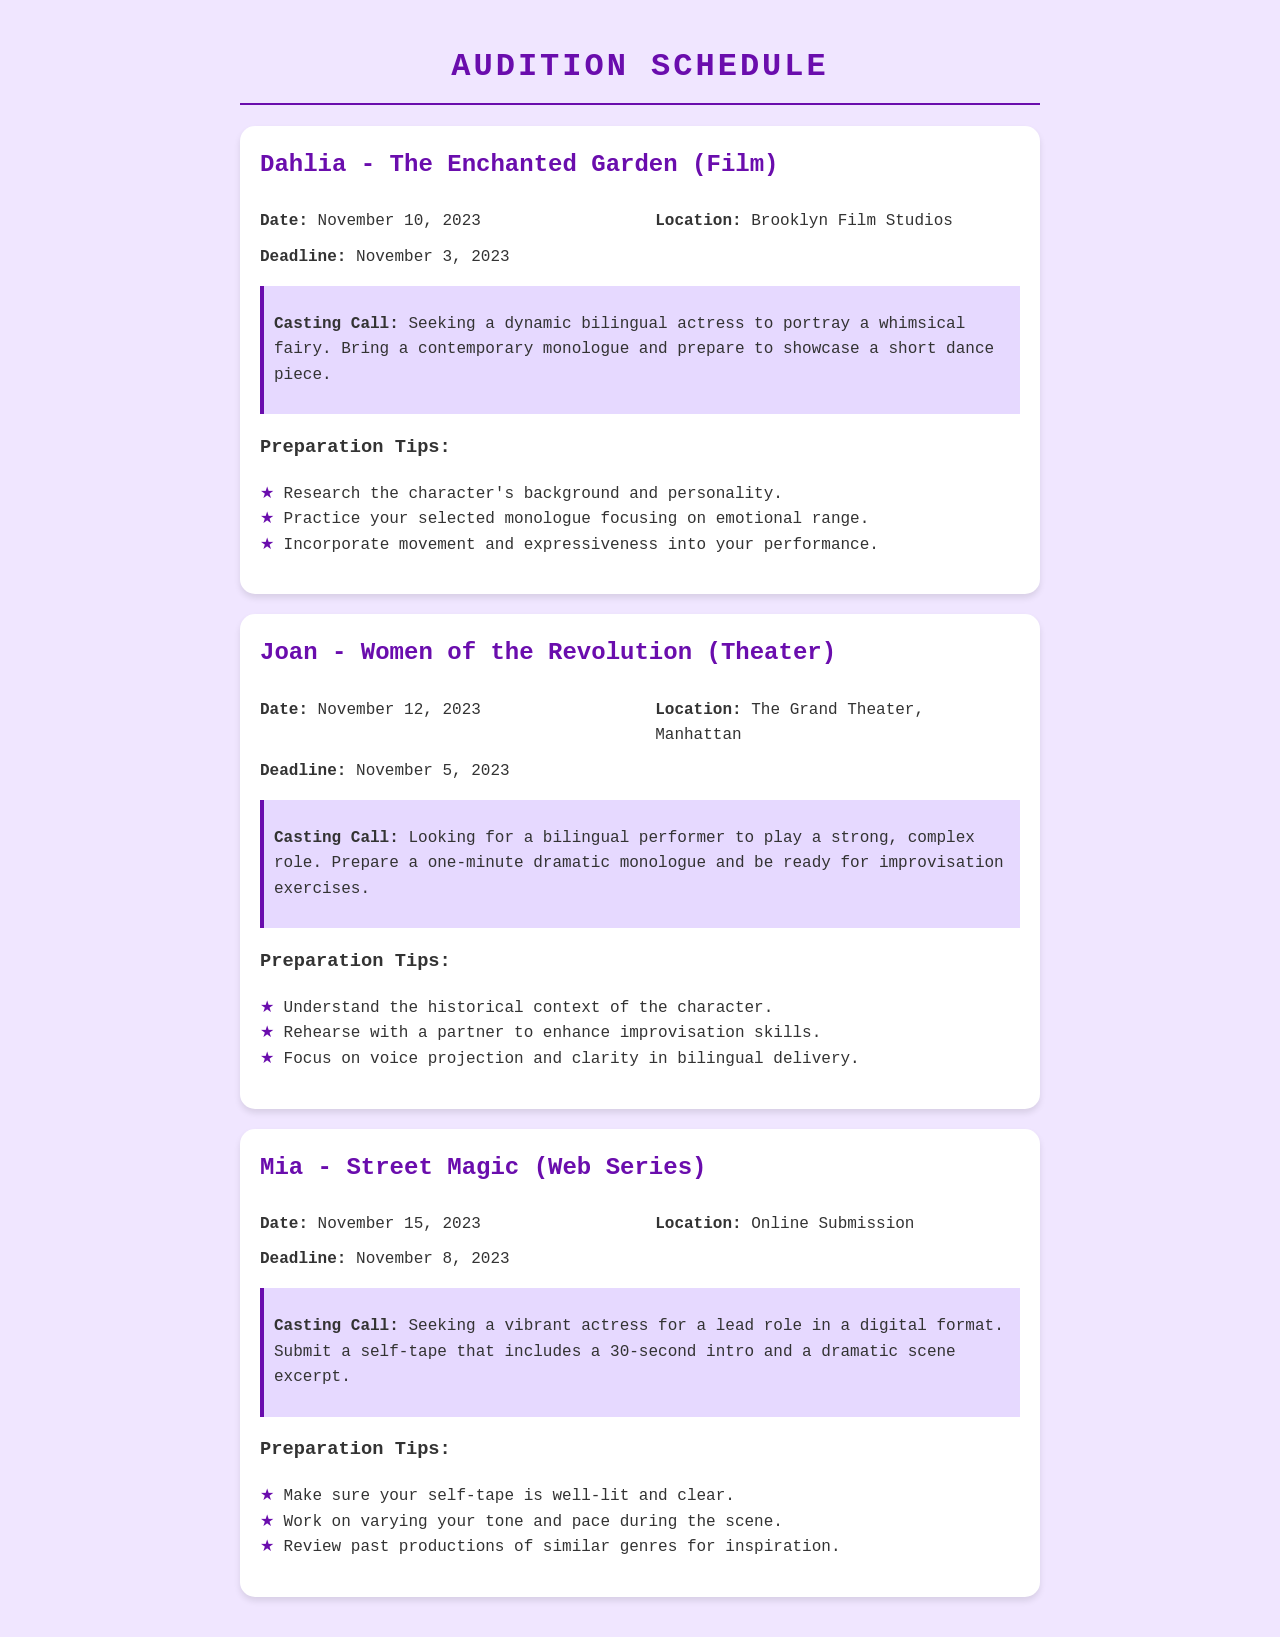What is the role for the film "The Enchanted Garden"? The document specifies that the role for the film "The Enchanted Garden" is Dahlia.
Answer: Dahlia What is the audition date for "Women of the Revolution"? The audition date for "Women of the Revolution" is mentioned as November 12, 2023.
Answer: November 12, 2023 Where is the audition for Mia taking place? The audition for Mia in the web series "Street Magic" is taking place online.
Answer: Online Submission What is the casting call requirement for the role of Dahlia? The casting call specifies bringing a contemporary monologue and showcasing a short dance piece.
Answer: A contemporary monologue and a short dance piece What should performers focus on for improvisation in "Women of the Revolution"? The document advises performers to rehearse with a partner to enhance improvisation skills.
Answer: Rehearse with a partner What is the self-tape requirement for the character Mia? The document states that the self-tape must include a 30-second intro and a dramatic scene excerpt.
Answer: A 30-second intro and a dramatic scene excerpt What deadline is set for the role of Dahlia? The deadline for the role of Dahlia is mentioned as November 3, 2023.
Answer: November 3, 2023 Which role requires voice projection and clarity in bilingual delivery? The role that requires voice projection and clarity in bilingual delivery is Joan in "Women of the Revolution."
Answer: Joan What preparation tip is suggested for self-taping? The document suggests ensuring the self-tape is well-lit and clear.
Answer: Well-lit and clear 